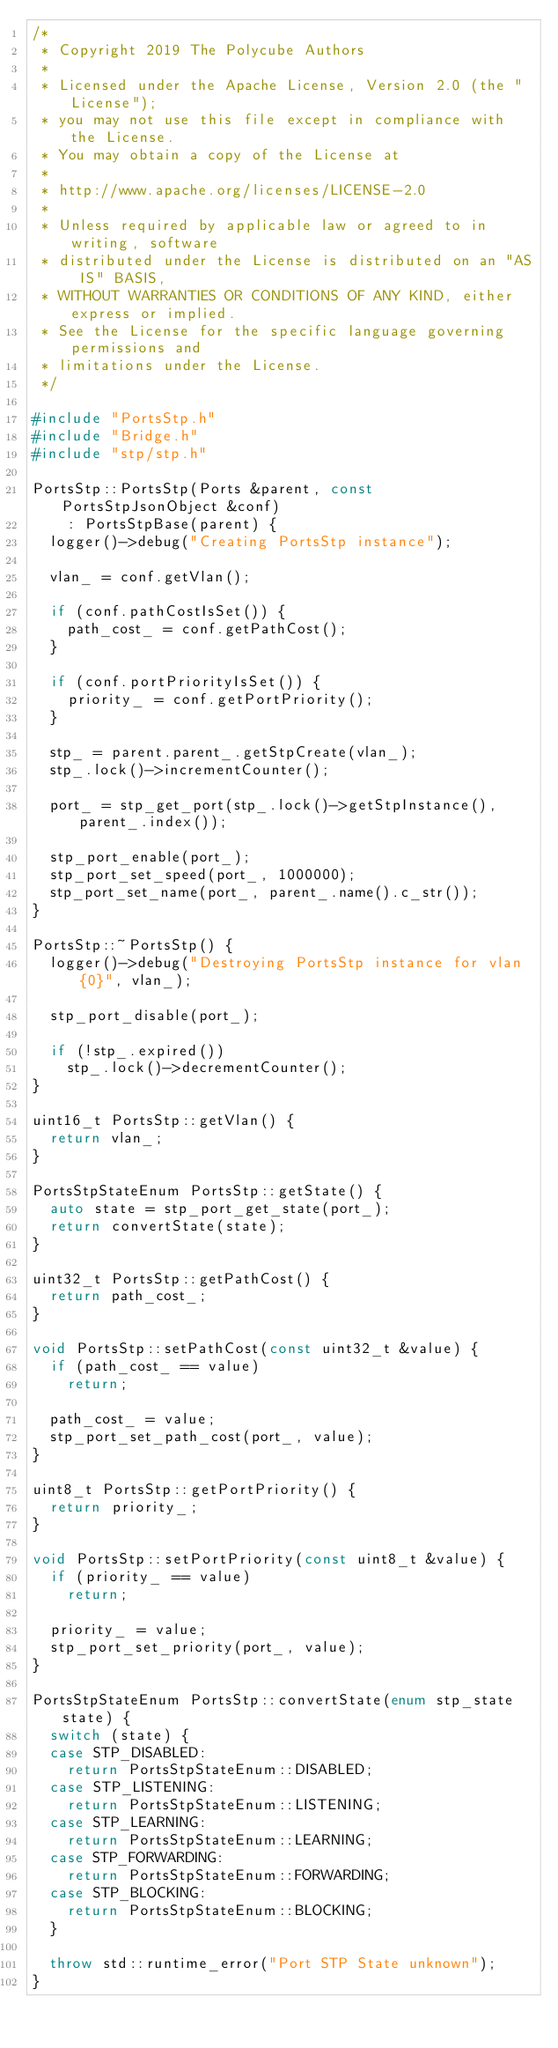Convert code to text. <code><loc_0><loc_0><loc_500><loc_500><_C++_>/*
 * Copyright 2019 The Polycube Authors
 *
 * Licensed under the Apache License, Version 2.0 (the "License");
 * you may not use this file except in compliance with the License.
 * You may obtain a copy of the License at
 *
 * http://www.apache.org/licenses/LICENSE-2.0
 *
 * Unless required by applicable law or agreed to in writing, software
 * distributed under the License is distributed on an "AS IS" BASIS,
 * WITHOUT WARRANTIES OR CONDITIONS OF ANY KIND, either express or implied.
 * See the License for the specific language governing permissions and
 * limitations under the License.
 */

#include "PortsStp.h"
#include "Bridge.h"
#include "stp/stp.h"

PortsStp::PortsStp(Ports &parent, const PortsStpJsonObject &conf)
    : PortsStpBase(parent) {
  logger()->debug("Creating PortsStp instance");

  vlan_ = conf.getVlan();

  if (conf.pathCostIsSet()) {
    path_cost_ = conf.getPathCost();
  }

  if (conf.portPriorityIsSet()) {
    priority_ = conf.getPortPriority();
  }

  stp_ = parent.parent_.getStpCreate(vlan_);
  stp_.lock()->incrementCounter();

  port_ = stp_get_port(stp_.lock()->getStpInstance(), parent_.index());

  stp_port_enable(port_);
  stp_port_set_speed(port_, 1000000);
  stp_port_set_name(port_, parent_.name().c_str());
}

PortsStp::~PortsStp() {
  logger()->debug("Destroying PortsStp instance for vlan {0}", vlan_);

  stp_port_disable(port_);

  if (!stp_.expired())
    stp_.lock()->decrementCounter();
}

uint16_t PortsStp::getVlan() {
  return vlan_;
}

PortsStpStateEnum PortsStp::getState() {
  auto state = stp_port_get_state(port_);
  return convertState(state);
}

uint32_t PortsStp::getPathCost() {
  return path_cost_;
}

void PortsStp::setPathCost(const uint32_t &value) {
  if (path_cost_ == value)
    return;

  path_cost_ = value;
  stp_port_set_path_cost(port_, value);
}

uint8_t PortsStp::getPortPriority() {
  return priority_;
}

void PortsStp::setPortPriority(const uint8_t &value) {
  if (priority_ == value)
    return;

  priority_ = value;
  stp_port_set_priority(port_, value);
}

PortsStpStateEnum PortsStp::convertState(enum stp_state state) {
  switch (state) {
  case STP_DISABLED:
    return PortsStpStateEnum::DISABLED;
  case STP_LISTENING:
    return PortsStpStateEnum::LISTENING;
  case STP_LEARNING:
    return PortsStpStateEnum::LEARNING;
  case STP_FORWARDING:
    return PortsStpStateEnum::FORWARDING;
  case STP_BLOCKING:
    return PortsStpStateEnum::BLOCKING;
  }

  throw std::runtime_error("Port STP State unknown");
}
</code> 